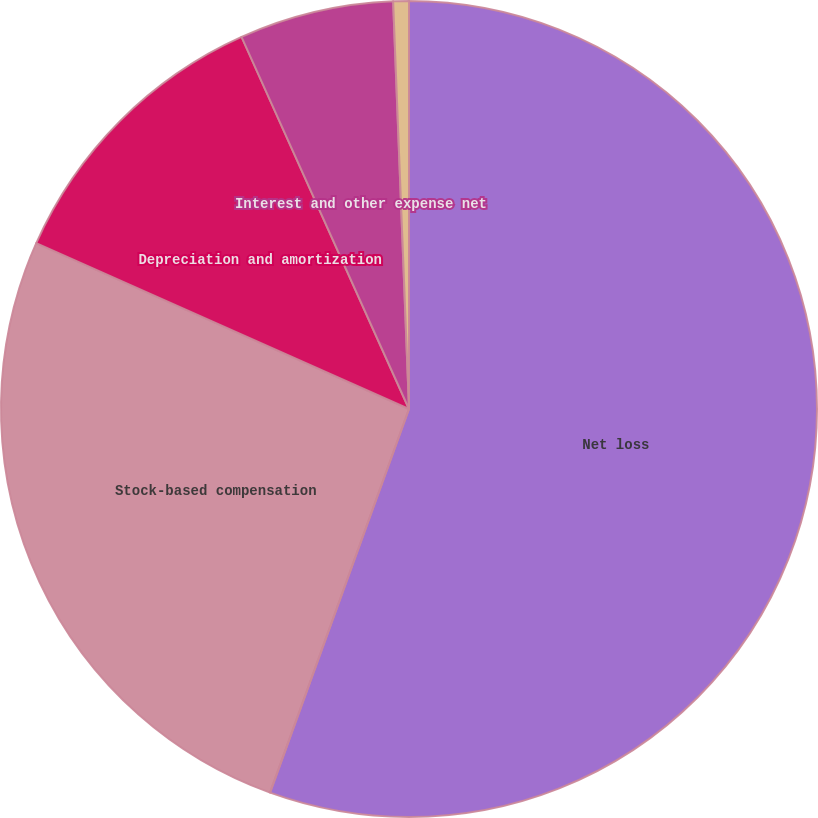Convert chart. <chart><loc_0><loc_0><loc_500><loc_500><pie_chart><fcel>Net loss<fcel>Stock-based compensation<fcel>Depreciation and amortization<fcel>Interest and other expense net<fcel>Provision (benefit) for income<nl><fcel>55.52%<fcel>26.13%<fcel>11.6%<fcel>6.11%<fcel>0.62%<nl></chart> 